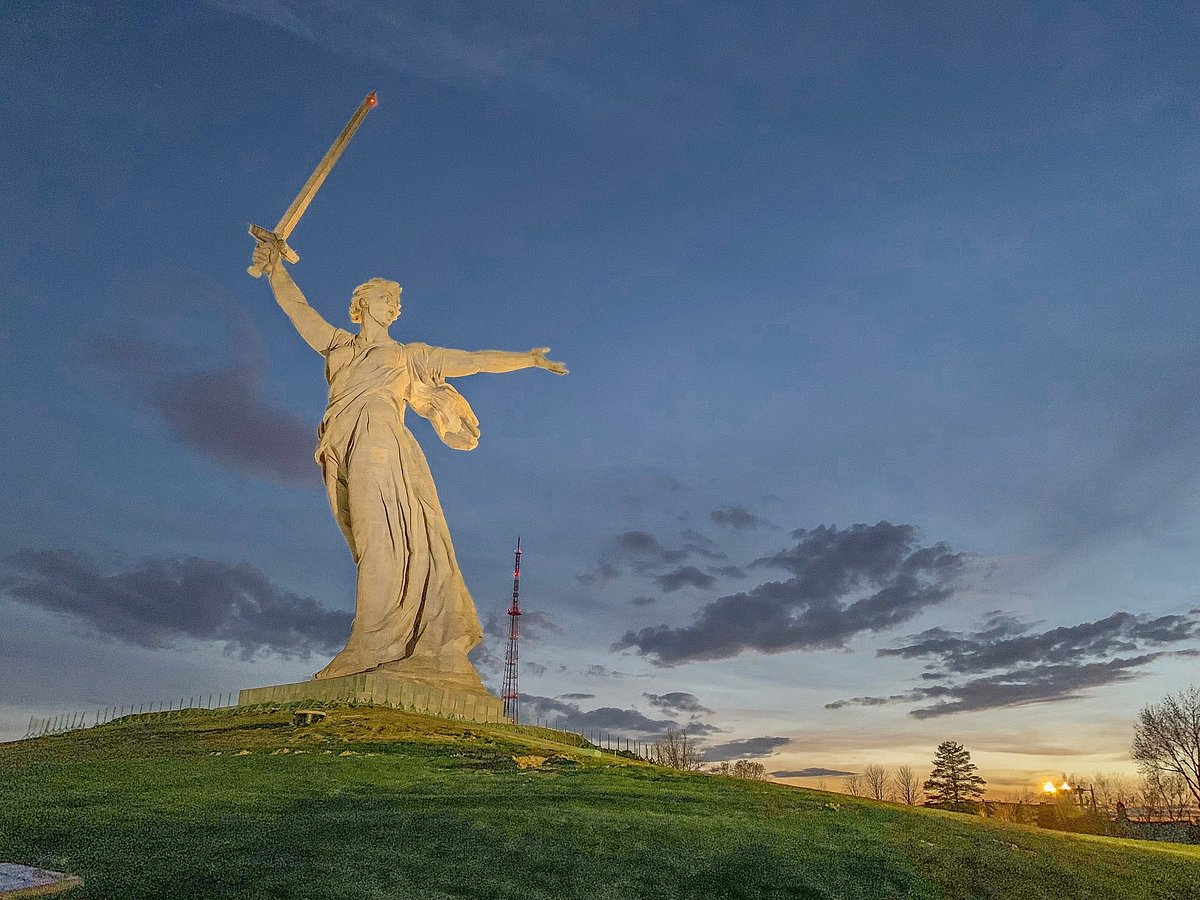Explain the visual content of the image in great detail. The image captures a striking view of the colossal statue known as 'The Motherland Calls,' an iconic monument in Russia. The statue depicts a formidable woman brandishing a sword high in her left hand, while her right hand is stretched outwards, symbolizing a call to arms or national pride. The statue stands majestically atop a verdant hill, with patches of green grass and scattered trees accentuating its base. The backdrop is a mesmerizing sky, awash with the orange and blue hues of twilight, amplifying the statue’s splendor. Taken from a low angle, the photo accentuates the monument's grandeur, making it appear even more imposing. In the distance, a red and white radio tower punctuates the skyline, juxtaposing modernity with historic symbolism. The statue's golden sword, catching the remnants of the setting sun's rays, stands out vividly against the sky, reinforcing the monument's grandeur and its significance as a symbol of resilience and strength. 